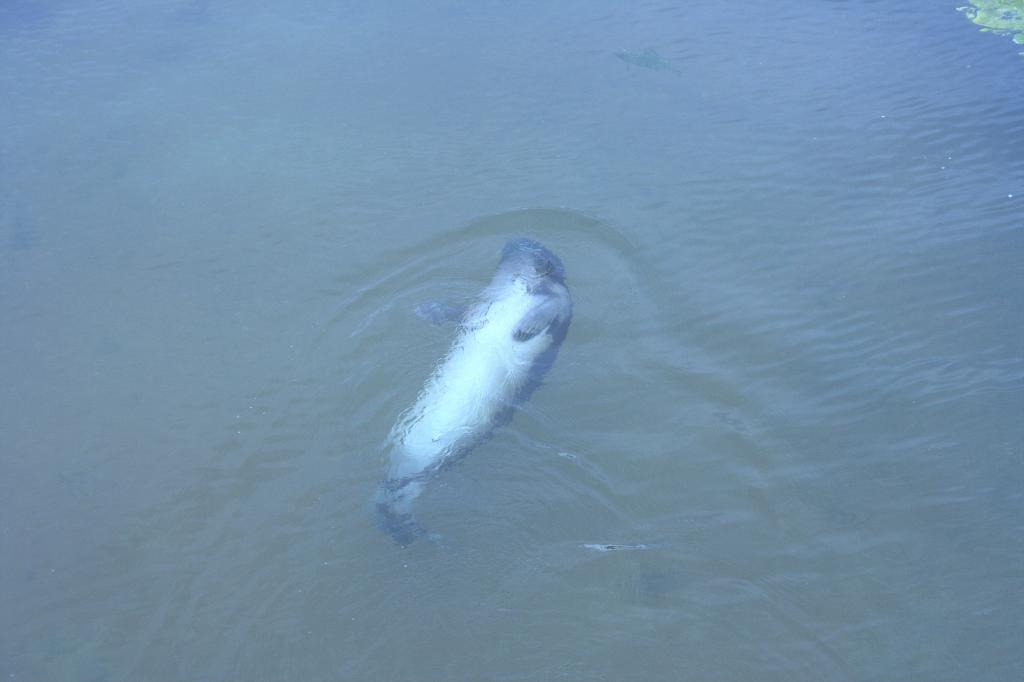What type of animal can be seen in the water? There is a fish in the water. What type of pest can be seen in the image? There is no pest present in the image; it features a fish in the water. What can the fish be used for in the image? The image does not show the fish being used for any specific purpose, as it is simply swimming in the water. 